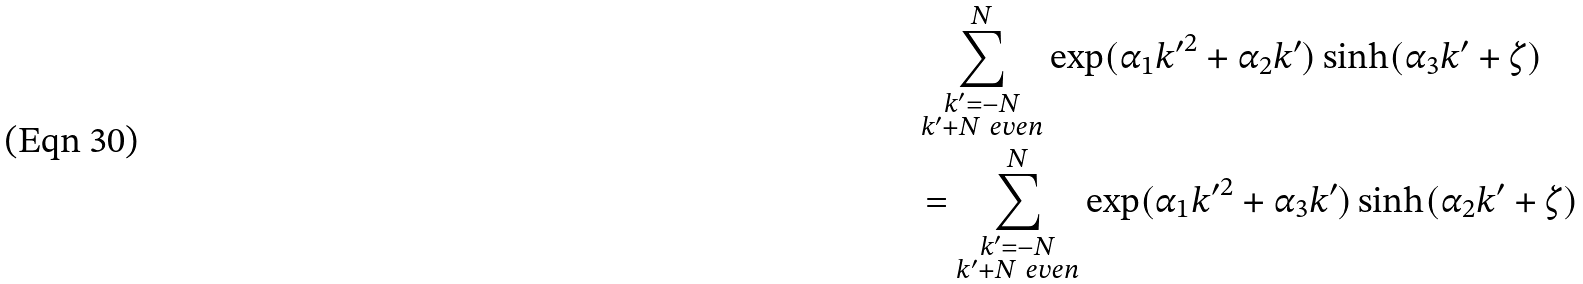Convert formula to latex. <formula><loc_0><loc_0><loc_500><loc_500>& \sum _ { \substack { k ^ { \prime } = - N \\ k ^ { \prime } + N \ e v e n } } ^ { N } \exp ( \alpha _ { 1 } { k ^ { \prime } } ^ { 2 } + \alpha _ { 2 } k ^ { \prime } ) \sinh ( \alpha _ { 3 } k ^ { \prime } + \zeta ) \\ & = \sum _ { \substack { k ^ { \prime } = - N \\ k ^ { \prime } + N \ e v e n } } ^ { N } \exp ( \alpha _ { 1 } { k ^ { \prime } } ^ { 2 } + \alpha _ { 3 } k ^ { \prime } ) \sinh ( \alpha _ { 2 } k ^ { \prime } + \zeta )</formula> 